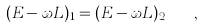Convert formula to latex. <formula><loc_0><loc_0><loc_500><loc_500>( E - \omega L ) _ { 1 } = ( E - \omega L ) _ { 2 } \quad ,</formula> 